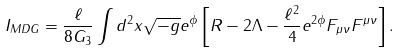Convert formula to latex. <formula><loc_0><loc_0><loc_500><loc_500>I _ { M D G } = \frac { \ell } { 8 G _ { 3 } } \int d ^ { 2 } x \sqrt { - g } e ^ { \phi } \left [ R - 2 \Lambda - \frac { \ell ^ { 2 } } { 4 } e ^ { 2 \phi } F _ { \mu \nu } F ^ { \mu \nu } \right ] .</formula> 